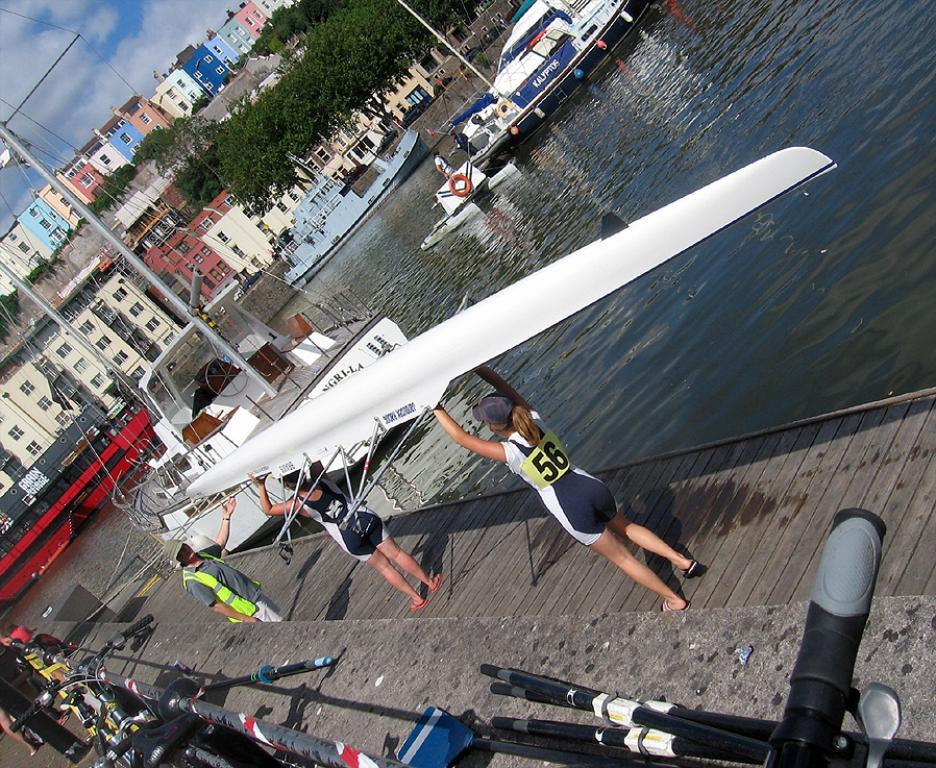<image>
Render a clear and concise summary of the photo. Rower number 56 helps hold a boat over her head with another rower. 